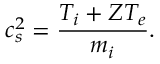Convert formula to latex. <formula><loc_0><loc_0><loc_500><loc_500>c _ { s } ^ { 2 } = \frac { T _ { i } + Z T _ { e } } { m _ { i } } .</formula> 